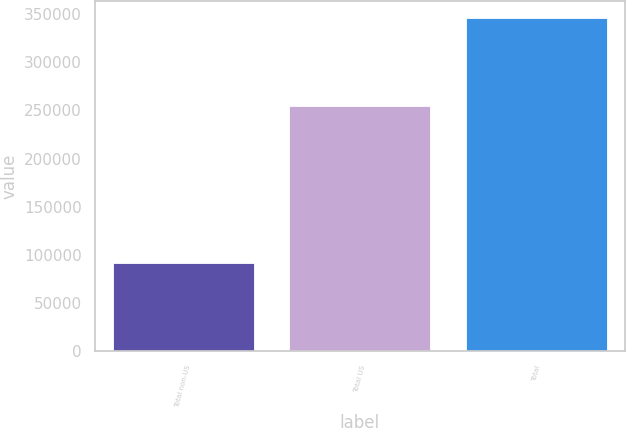<chart> <loc_0><loc_0><loc_500><loc_500><bar_chart><fcel>Total non-US<fcel>Total US<fcel>Total<nl><fcel>91739<fcel>254340<fcel>346079<nl></chart> 